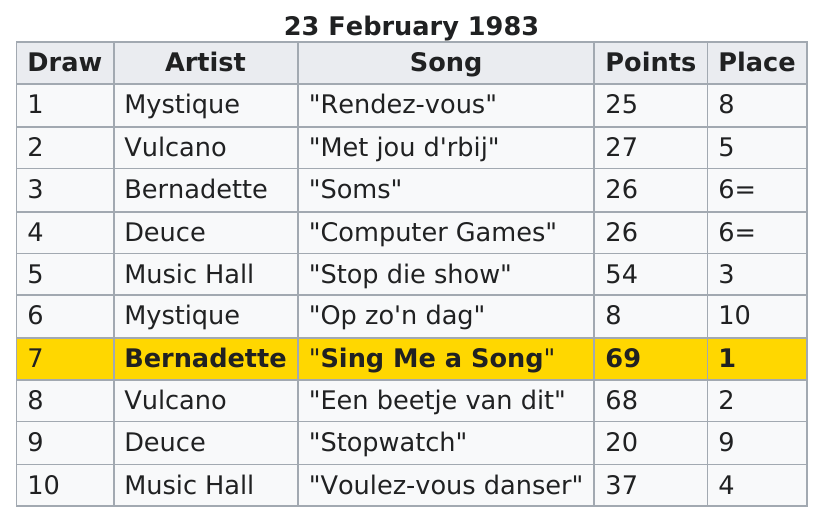Point out several critical features in this image. The number of artists who ended up in 6th place is 2. The total of points on the chart is 360. Deuce 'Stopwatch' had the least amount of points next to Mystique's 'Op zo'n dag'. Mystique, the artist who scored the least amount of points, is the one who did not perform well. In the X-Men comics, Mystique earned the least number of points among all the artists. 